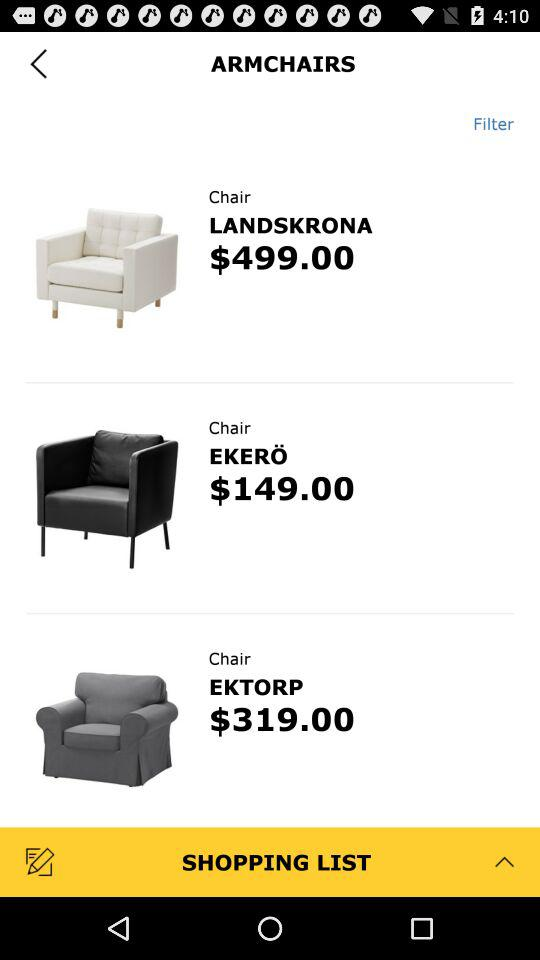How many items are in the shopping list?
When the provided information is insufficient, respond with <no answer>. <no answer> 